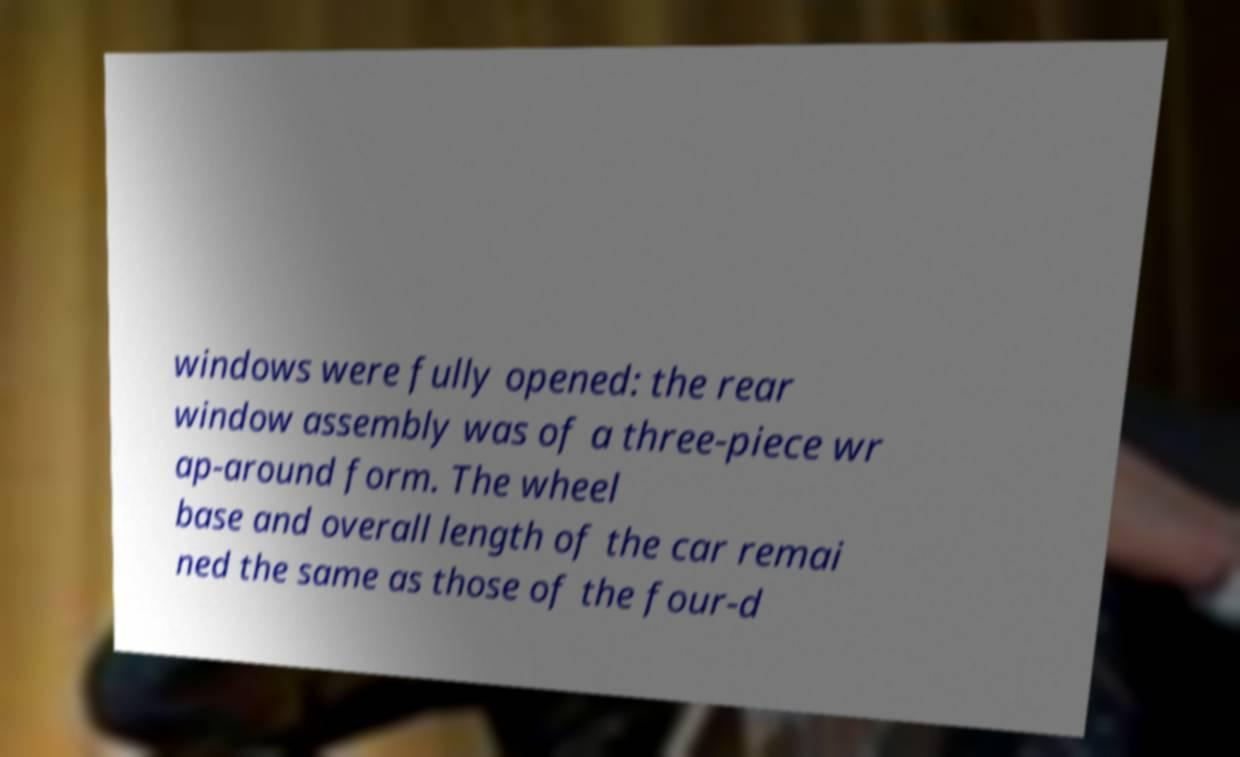There's text embedded in this image that I need extracted. Can you transcribe it verbatim? windows were fully opened: the rear window assembly was of a three-piece wr ap-around form. The wheel base and overall length of the car remai ned the same as those of the four-d 